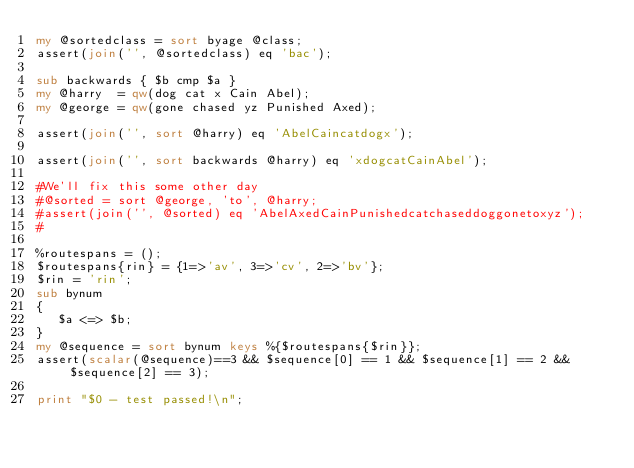Convert code to text. <code><loc_0><loc_0><loc_500><loc_500><_Perl_>my @sortedclass = sort byage @class;
assert(join('', @sortedclass) eq 'bac');

sub backwards { $b cmp $a }
my @harry  = qw(dog cat x Cain Abel);
my @george = qw(gone chased yz Punished Axed);

assert(join('', sort @harry) eq 'AbelCaincatdogx');

assert(join('', sort backwards @harry) eq 'xdogcatCainAbel');

#We'll fix this some other day
#@sorted = sort @george, 'to', @harry;
#assert(join('', @sorted) eq 'AbelAxedCainPunishedcatchaseddoggonetoxyz');
#

%routespans = ();
$routespans{rin} = {1=>'av', 3=>'cv', 2=>'bv'};
$rin = 'rin';
sub bynum
{
   $a <=> $b;
}
my @sequence = sort bynum keys %{$routespans{$rin}};
assert(scalar(@sequence)==3 && $sequence[0] == 1 && $sequence[1] == 2 && $sequence[2] == 3);

print "$0 - test passed!\n";
</code> 